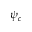Convert formula to latex. <formula><loc_0><loc_0><loc_500><loc_500>\psi _ { c }</formula> 